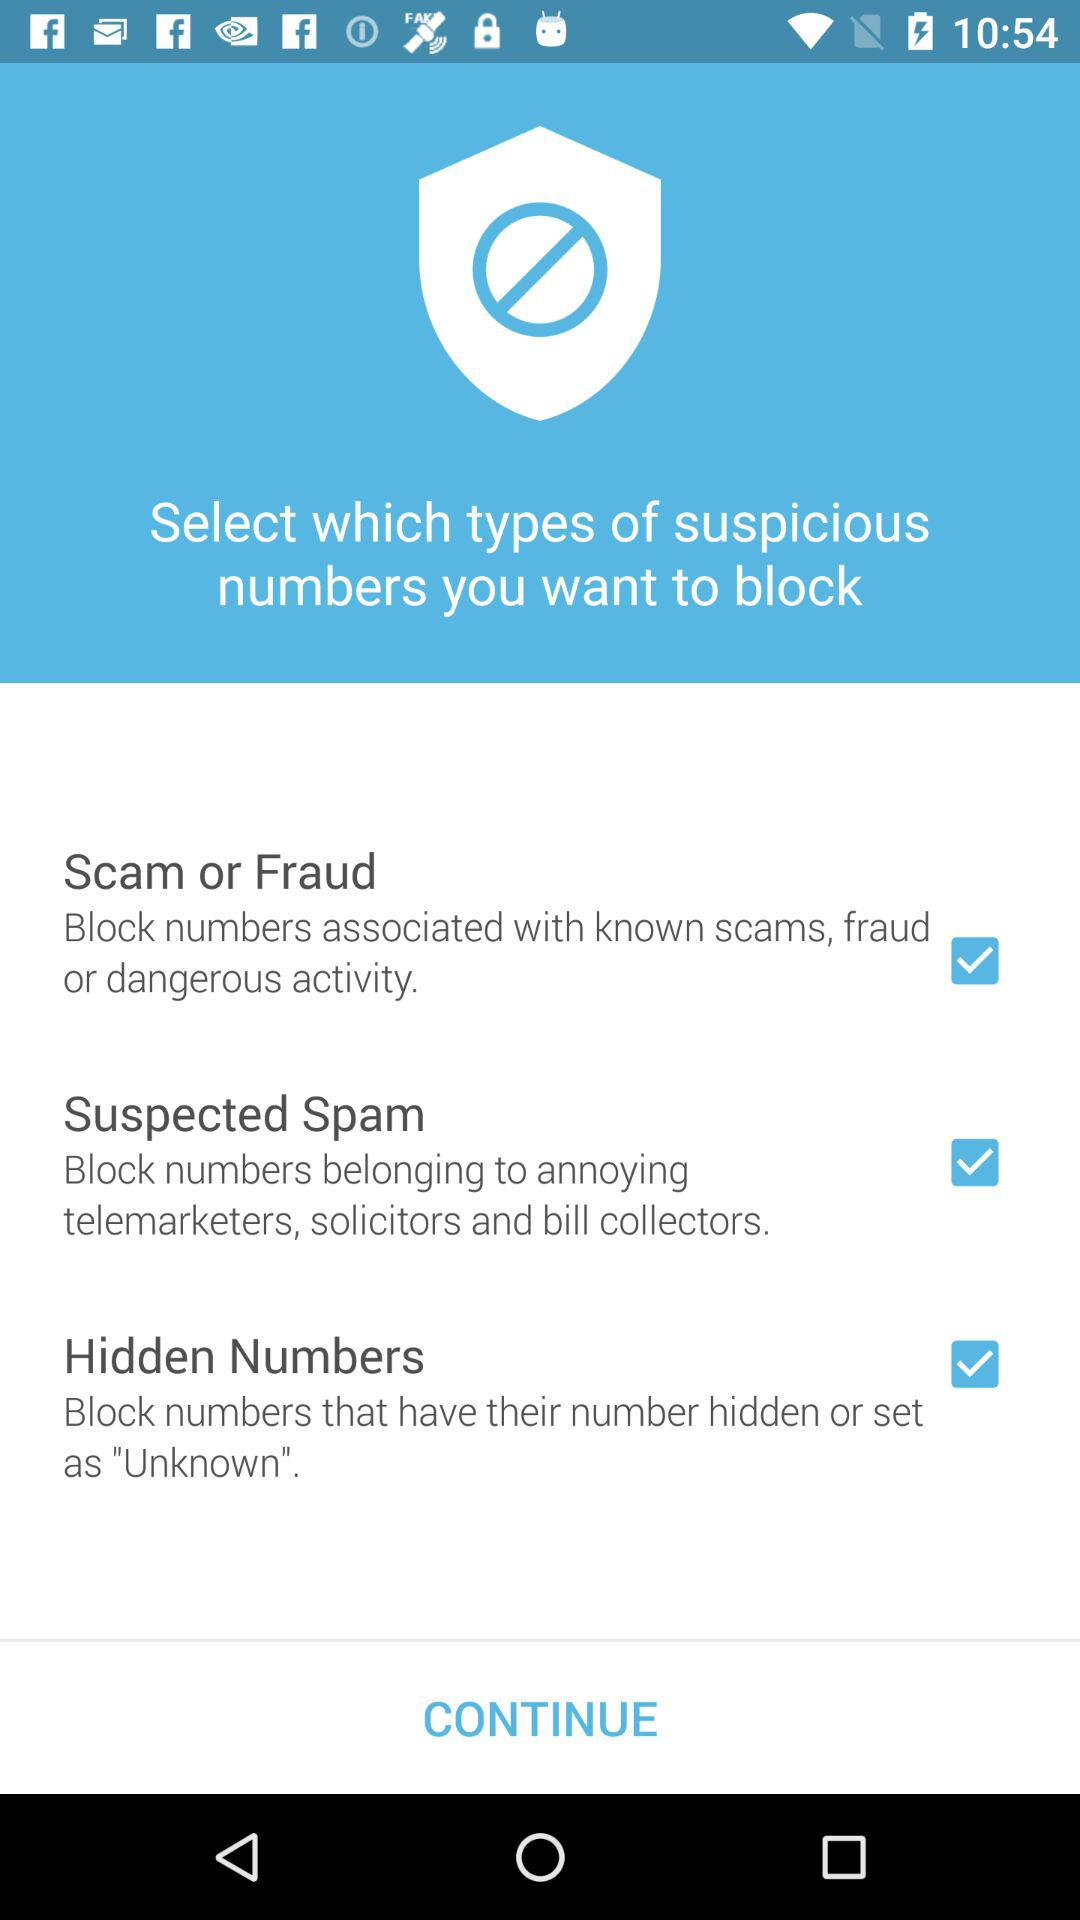Which settings are checked? The checked settings are "Scam or Fraud", "Suspected Spam" and "Hidden Numbers". 